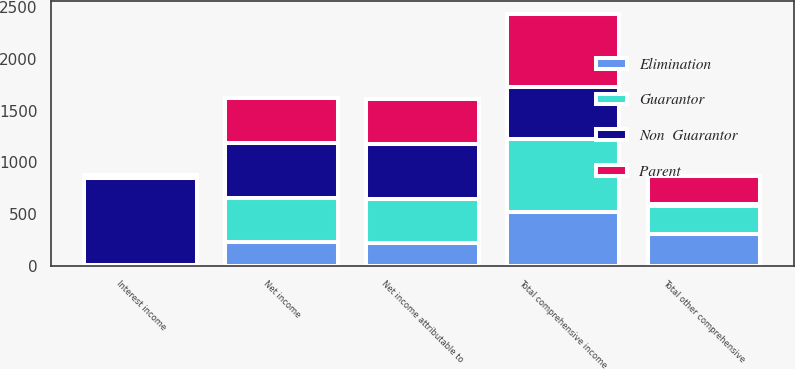Convert chart. <chart><loc_0><loc_0><loc_500><loc_500><stacked_bar_chart><ecel><fcel>Interest income<fcel>Net income<fcel>Net income attributable to<fcel>Total other comprehensive<fcel>Total comprehensive income<nl><fcel>Guarantor<fcel>1<fcel>429<fcel>429<fcel>271<fcel>700<nl><fcel>Non  Guarantor<fcel>839<fcel>529<fcel>529<fcel>21<fcel>508<nl><fcel>Parent<fcel>37<fcel>433<fcel>433<fcel>271<fcel>704<nl><fcel>Elimination<fcel>4<fcel>229<fcel>218<fcel>306<fcel>524<nl></chart> 